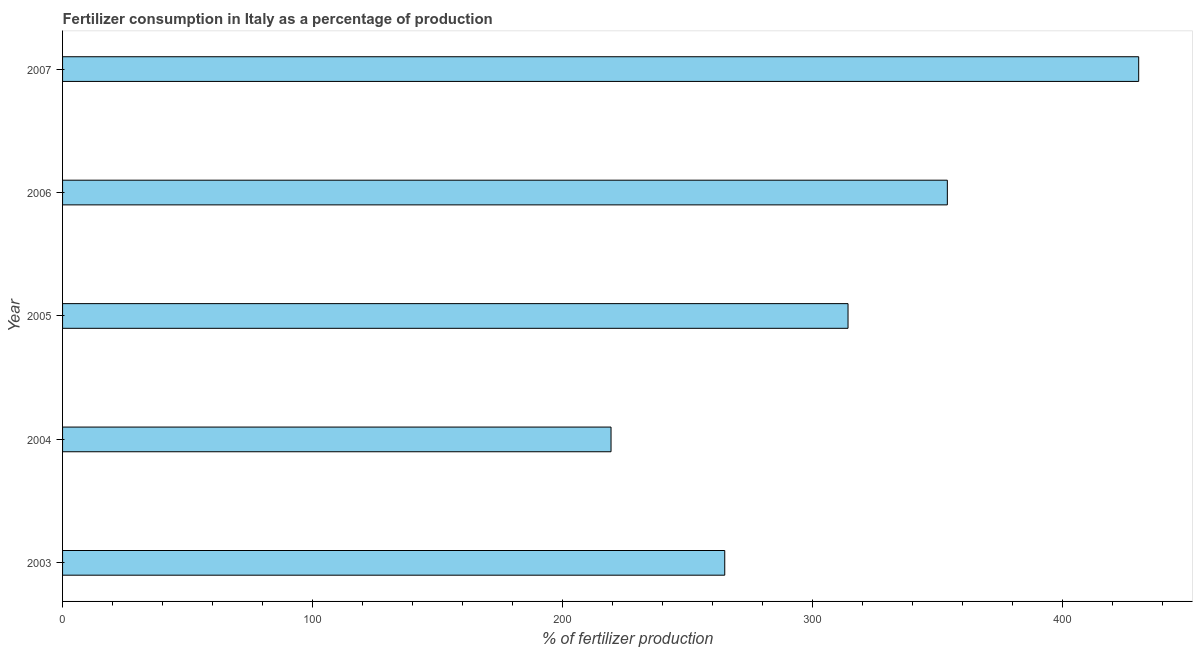Does the graph contain grids?
Offer a very short reply. No. What is the title of the graph?
Give a very brief answer. Fertilizer consumption in Italy as a percentage of production. What is the label or title of the X-axis?
Offer a terse response. % of fertilizer production. What is the amount of fertilizer consumption in 2004?
Provide a succinct answer. 219.45. Across all years, what is the maximum amount of fertilizer consumption?
Your answer should be very brief. 430.56. Across all years, what is the minimum amount of fertilizer consumption?
Offer a very short reply. 219.45. In which year was the amount of fertilizer consumption maximum?
Keep it short and to the point. 2007. In which year was the amount of fertilizer consumption minimum?
Offer a very short reply. 2004. What is the sum of the amount of fertilizer consumption?
Your answer should be compact. 1583.23. What is the difference between the amount of fertilizer consumption in 2004 and 2006?
Offer a very short reply. -134.56. What is the average amount of fertilizer consumption per year?
Offer a terse response. 316.65. What is the median amount of fertilizer consumption?
Your response must be concise. 314.27. In how many years, is the amount of fertilizer consumption greater than 20 %?
Your answer should be very brief. 5. Do a majority of the years between 2007 and 2005 (inclusive) have amount of fertilizer consumption greater than 40 %?
Make the answer very short. Yes. What is the ratio of the amount of fertilizer consumption in 2003 to that in 2004?
Your answer should be very brief. 1.21. Is the amount of fertilizer consumption in 2003 less than that in 2004?
Provide a succinct answer. No. What is the difference between the highest and the second highest amount of fertilizer consumption?
Your response must be concise. 76.56. Is the sum of the amount of fertilizer consumption in 2004 and 2007 greater than the maximum amount of fertilizer consumption across all years?
Give a very brief answer. Yes. What is the difference between the highest and the lowest amount of fertilizer consumption?
Keep it short and to the point. 211.12. In how many years, is the amount of fertilizer consumption greater than the average amount of fertilizer consumption taken over all years?
Ensure brevity in your answer.  2. How many bars are there?
Make the answer very short. 5. Are all the bars in the graph horizontal?
Your answer should be very brief. Yes. Are the values on the major ticks of X-axis written in scientific E-notation?
Offer a terse response. No. What is the % of fertilizer production in 2003?
Offer a very short reply. 264.94. What is the % of fertilizer production of 2004?
Offer a terse response. 219.45. What is the % of fertilizer production of 2005?
Give a very brief answer. 314.27. What is the % of fertilizer production of 2006?
Give a very brief answer. 354.01. What is the % of fertilizer production of 2007?
Give a very brief answer. 430.56. What is the difference between the % of fertilizer production in 2003 and 2004?
Ensure brevity in your answer.  45.5. What is the difference between the % of fertilizer production in 2003 and 2005?
Ensure brevity in your answer.  -49.33. What is the difference between the % of fertilizer production in 2003 and 2006?
Give a very brief answer. -89.07. What is the difference between the % of fertilizer production in 2003 and 2007?
Your answer should be very brief. -165.62. What is the difference between the % of fertilizer production in 2004 and 2005?
Keep it short and to the point. -94.82. What is the difference between the % of fertilizer production in 2004 and 2006?
Make the answer very short. -134.56. What is the difference between the % of fertilizer production in 2004 and 2007?
Keep it short and to the point. -211.12. What is the difference between the % of fertilizer production in 2005 and 2006?
Provide a succinct answer. -39.74. What is the difference between the % of fertilizer production in 2005 and 2007?
Your answer should be compact. -116.29. What is the difference between the % of fertilizer production in 2006 and 2007?
Your answer should be compact. -76.56. What is the ratio of the % of fertilizer production in 2003 to that in 2004?
Make the answer very short. 1.21. What is the ratio of the % of fertilizer production in 2003 to that in 2005?
Your answer should be compact. 0.84. What is the ratio of the % of fertilizer production in 2003 to that in 2006?
Your answer should be compact. 0.75. What is the ratio of the % of fertilizer production in 2003 to that in 2007?
Offer a terse response. 0.61. What is the ratio of the % of fertilizer production in 2004 to that in 2005?
Your answer should be very brief. 0.7. What is the ratio of the % of fertilizer production in 2004 to that in 2006?
Your answer should be very brief. 0.62. What is the ratio of the % of fertilizer production in 2004 to that in 2007?
Give a very brief answer. 0.51. What is the ratio of the % of fertilizer production in 2005 to that in 2006?
Your answer should be compact. 0.89. What is the ratio of the % of fertilizer production in 2005 to that in 2007?
Offer a very short reply. 0.73. What is the ratio of the % of fertilizer production in 2006 to that in 2007?
Ensure brevity in your answer.  0.82. 